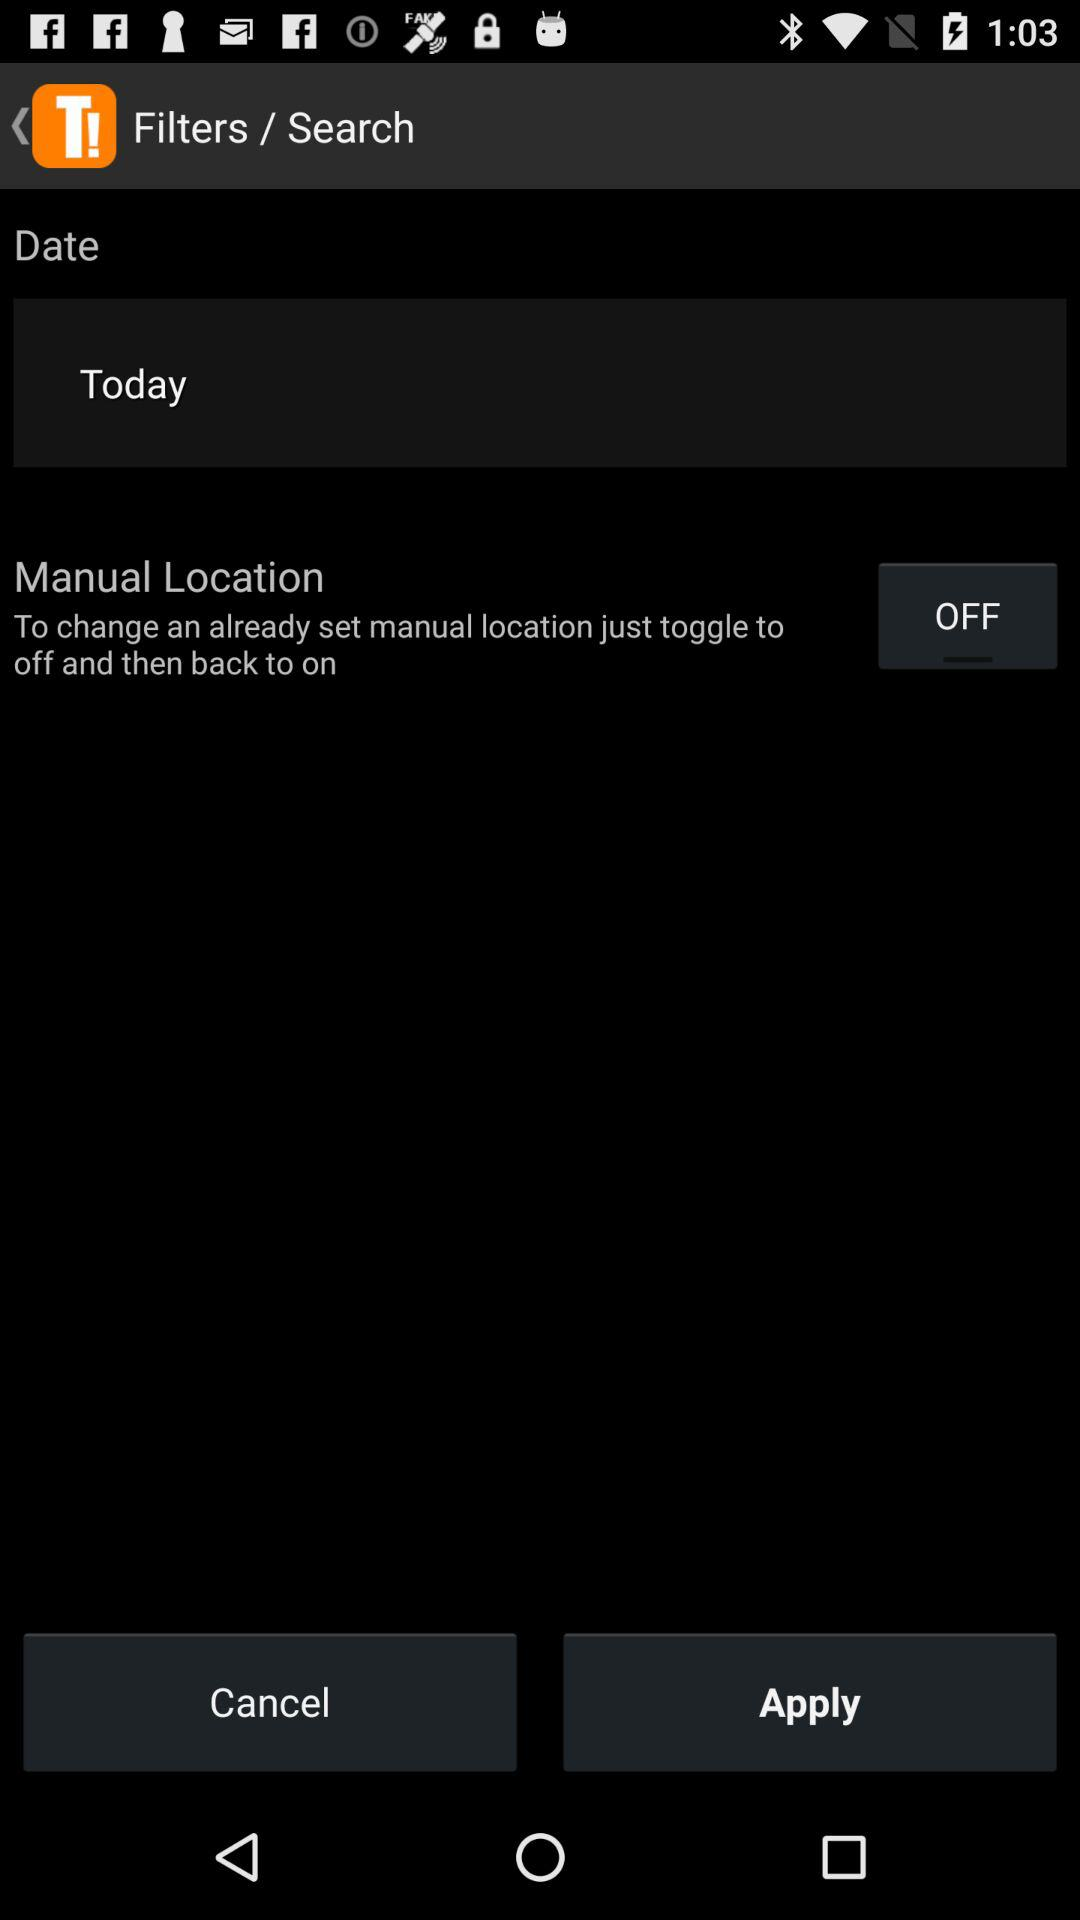Is "Today" checked or unchecked?
When the provided information is insufficient, respond with <no answer>. <no answer> 